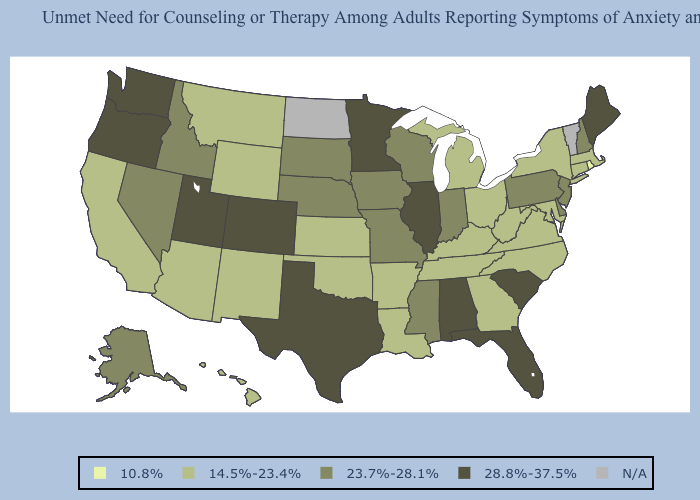What is the highest value in the Northeast ?
Keep it brief. 28.8%-37.5%. What is the highest value in the USA?
Short answer required. 28.8%-37.5%. Name the states that have a value in the range 10.8%?
Short answer required. Rhode Island. Does the first symbol in the legend represent the smallest category?
Be succinct. Yes. Does Montana have the highest value in the West?
Answer briefly. No. What is the value of Arkansas?
Concise answer only. 14.5%-23.4%. What is the value of New York?
Answer briefly. 14.5%-23.4%. How many symbols are there in the legend?
Answer briefly. 5. Does the map have missing data?
Write a very short answer. Yes. Does the map have missing data?
Give a very brief answer. Yes. Among the states that border Florida , does Georgia have the lowest value?
Be succinct. Yes. What is the lowest value in the MidWest?
Quick response, please. 14.5%-23.4%. What is the value of Wisconsin?
Answer briefly. 23.7%-28.1%. What is the value of Colorado?
Concise answer only. 28.8%-37.5%. 